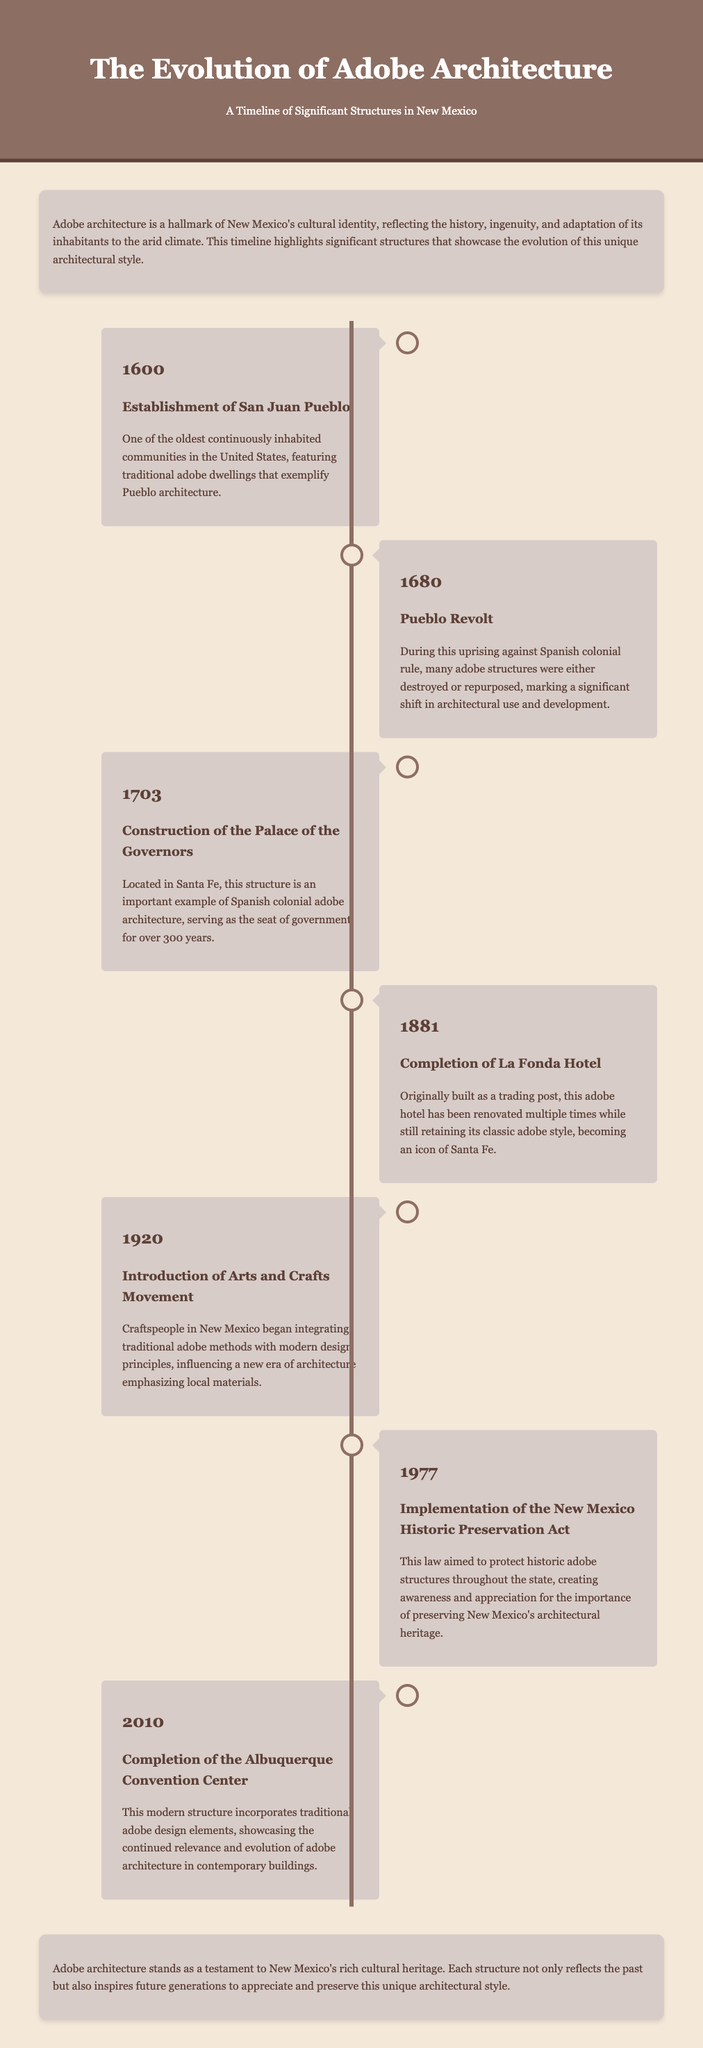What year was San Juan Pueblo established? San Juan Pueblo is noted as being established in 1600 in the document.
Answer: 1600 What significant event took place in 1680? The document states that the Pueblo Revolt occurred in 1680, which impacted adobe structures.
Answer: Pueblo Revolt What architectural structure was constructed in 1703? The document specifically names the Palace of the Governors as constructed in 1703.
Answer: Palace of the Governors Which hotel was completed in 1881? The document mentions La Fonda Hotel was completed in 1881, highlighting its significance.
Answer: La Fonda Hotel What influence did the Arts and Crafts Movement have in 1920? The document describes that the movement influenced New Mexico craftspeople to integrate traditional adobe methods with modern design principles.
Answer: Integration of traditional adobe methods What legislation was enacted in 1977? The New Mexico Historic Preservation Act was implemented in 1977 as stated in the document.
Answer: New Mexico Historic Preservation Act What structure was completed in 2010? The Albuquerque Convention Center is noted in the document as being completed in 2010.
Answer: Albuquerque Convention Center What is the overall theme of the timeline? The timeline showcases the evolution and significance of adobe architecture in New Mexico.
Answer: Evolution of adobe architecture How has modern architecture incorporated traditional elements? The document mentions that modern structures continue to incorporate traditional adobe design elements.
Answer: Incorporation of traditional adobe design elements 